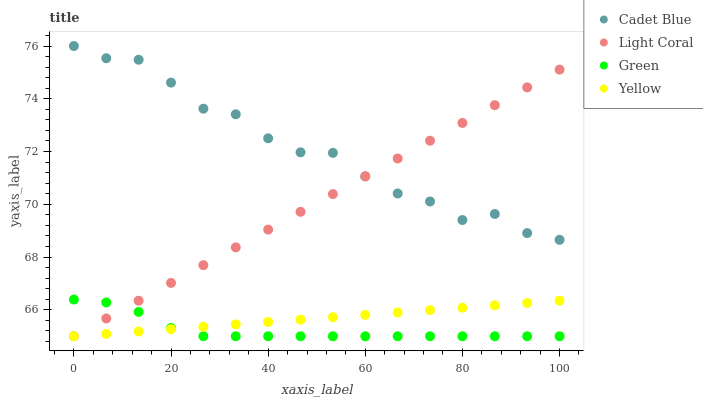Does Green have the minimum area under the curve?
Answer yes or no. Yes. Does Cadet Blue have the maximum area under the curve?
Answer yes or no. Yes. Does Cadet Blue have the minimum area under the curve?
Answer yes or no. No. Does Green have the maximum area under the curve?
Answer yes or no. No. Is Yellow the smoothest?
Answer yes or no. Yes. Is Cadet Blue the roughest?
Answer yes or no. Yes. Is Green the smoothest?
Answer yes or no. No. Is Green the roughest?
Answer yes or no. No. Does Light Coral have the lowest value?
Answer yes or no. Yes. Does Cadet Blue have the lowest value?
Answer yes or no. No. Does Cadet Blue have the highest value?
Answer yes or no. Yes. Does Green have the highest value?
Answer yes or no. No. Is Yellow less than Cadet Blue?
Answer yes or no. Yes. Is Cadet Blue greater than Yellow?
Answer yes or no. Yes. Does Light Coral intersect Green?
Answer yes or no. Yes. Is Light Coral less than Green?
Answer yes or no. No. Is Light Coral greater than Green?
Answer yes or no. No. Does Yellow intersect Cadet Blue?
Answer yes or no. No. 